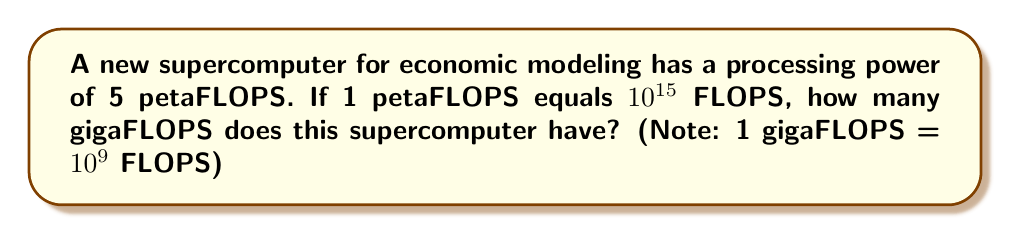Can you solve this math problem? To solve this problem, we need to convert petaFLOPS to gigaFLOPS. Let's break it down step-by-step:

1. First, let's convert petaFLOPS to FLOPS:
   $5 \text{ petaFLOPS} = 5 \times 10^{15} \text{ FLOPS}$

2. Now, we need to convert this to gigaFLOPS. We know that 1 gigaFLOPS = $10^9$ FLOPS.
   To find out how many gigaFLOPS, we divide the total FLOPS by $10^9$:

   $\frac{5 \times 10^{15} \text{ FLOPS}}{10^9 \text{ FLOPS/gigaFLOPS}} = 5 \times 10^6 \text{ gigaFLOPS}$

3. Simplify:
   $5 \times 10^6 \text{ gigaFLOPS} = 5,000,000 \text{ gigaFLOPS}$

Therefore, the supercomputer has 5,000,000 gigaFLOPS of processing power.
Answer: 5,000,000 gigaFLOPS 